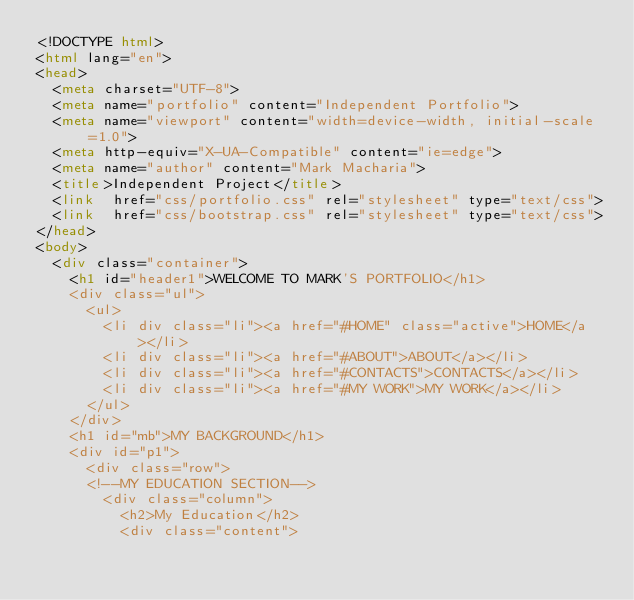<code> <loc_0><loc_0><loc_500><loc_500><_HTML_><!DOCTYPE html>
<html lang="en">
<head>
  <meta charset="UTF-8">
  <meta name="portfolio" content="Independent Portfolio">
  <meta name="viewport" content="width=device-width, initial-scale=1.0">
  <meta http-equiv="X-UA-Compatible" content="ie=edge">
  <meta name="author" content="Mark Macharia">
  <title>Independent Project</title>
  <link  href="css/portfolio.css" rel="stylesheet" type="text/css">
  <link  href="css/bootstrap.css" rel="stylesheet" type="text/css">
</head> 
<body>
  <div class="container">
    <h1 id="header1">WELCOME TO MARK'S PORTFOLIO</h1>
    <div class="ul">
      <ul>
        <li div class="li"><a href="#HOME" class="active">HOME</a></li>
        <li div class="li"><a href="#ABOUT">ABOUT</a></li>
        <li div class="li"><a href="#CONTACTS">CONTACTS</a></li>
        <li div class="li"><a href="#MY WORK">MY WORK</a></li>
      </ul>
    </div>
    <h1 id="mb">MY BACKGROUND</h1>
    <div id="p1">
      <div class="row">
      <!--MY EDUCATION SECTION-->
        <div class="column">
          <h2>My Education</h2>
          <div class="content"></code> 